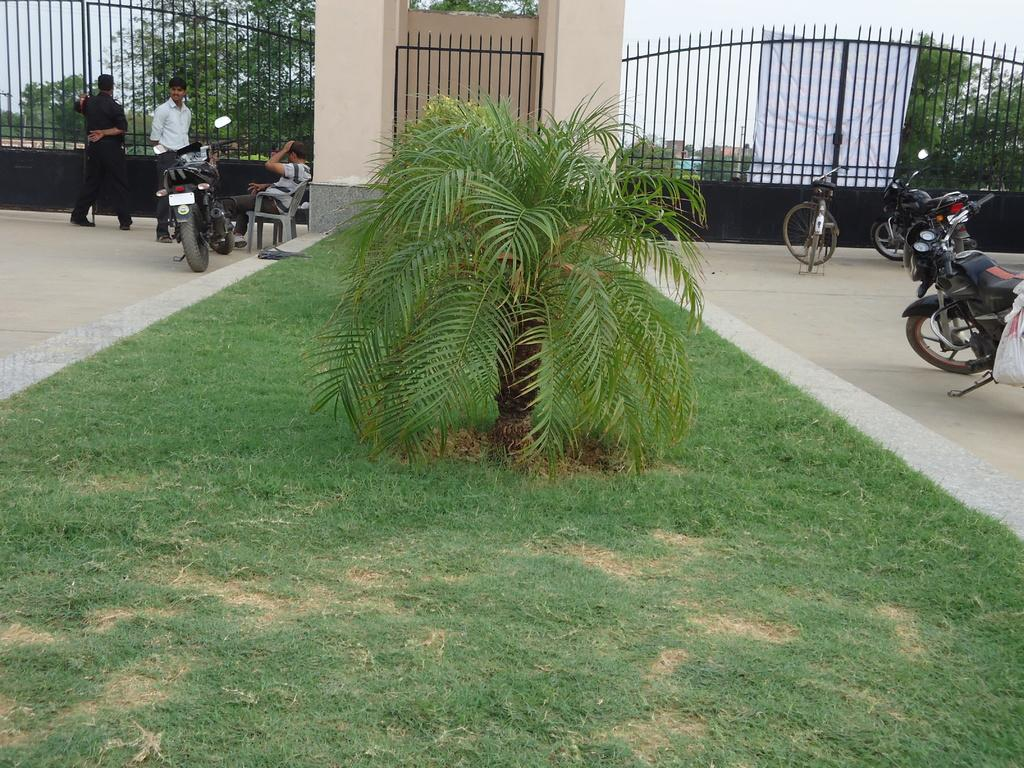What can be seen at the top of the image? There are gates at the top of the image. What is located in the middle of the image? There are vehicles in the middle of the image. What type of vegetation is present in the image? There are trees and bushes in the middle and top of the image. What type of ground cover is at the bottom of the image? There is grass at the bottom of the image. Can you tell me how many bears are sitting on the vehicles in the image? There are no bears present in the image; it features gates, vehicles, trees, bushes, and grass. Is there a shop visible in the image? There is no shop present in the image. 